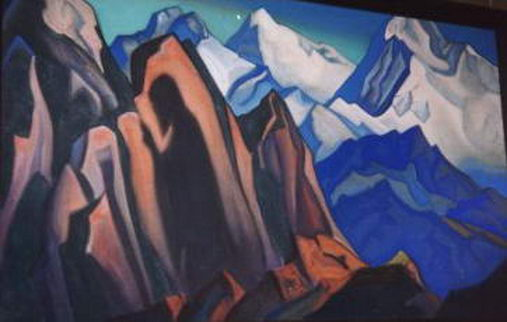Could you explain the mood that the artist might be trying to convey with this cubist mountain landscape? The artist appears to be conveying a blend of serenity and intensity through the cubist mountain landscape. The cool tones of blues and purples evoke a sense of calm and tranquility, reminiscent of a peaceful, yet majestic, natural setting. Simultaneously, the sharp geometric shapes and contrasting warm oranges introduce an element of intensity, suggesting the raw, unyielding nature of the mountains. The combination of these elements creates a balanced mood that is both soothing and powerful, inviting viewers to reflect on the awe-inspiring beauty and grandeur of the natural world. How might the choice of colors enhance the emotional experience of the viewer? The choice of colors in this painting profoundly enhances the emotional experience of the viewer. Cool colors like blues and purples typically evoke feelings of calmness, peacefulness, and introspection. These colors draw the viewer into a serene and meditative state, mirroring the quiet majesty of the mountain scene. On the other hand, the warmer oranges add a contrasting layer of energy and warmth, breaking the monotony and suggesting the dynamic and vibrant aspects of the landscape. This careful balance of color palettes creates a mood that is both calming and invigorating, deeply resonating with the viewer's emotional spectrum and drawing them into a contemplative exploration of the artwork. Imagine standing at the foot of these mountains. What might you see, hear, and feel? Standing at the foot of these mighty cubist mountains, you might first be struck by the grandeur and sheer scale of the towering peaks above. The geometric shapes, though abstract, paint a vivid picture of jagged rock faces, interlocking to form an intricate tapestry of natural beauty. The crisp, cool air would likely fill your lungs, invigorating you with each breath. You might hear the distant sound of wind whistling through the mountain passes, occasionally punctuated by the echoing call of birds in flight. A sense of profound stillness would envelop you, broken only by the subtle sounds of nature. The rugged texture of the rocks beneath your feet would remind you of the earth's ancient history, instilling a sense of awe and respect for this timeless landscape. This overwhelming feeling of being a small part of the vast natural world would be both humbling and exhilarating, giving you a deep appreciation for the majesty of the mountains. 